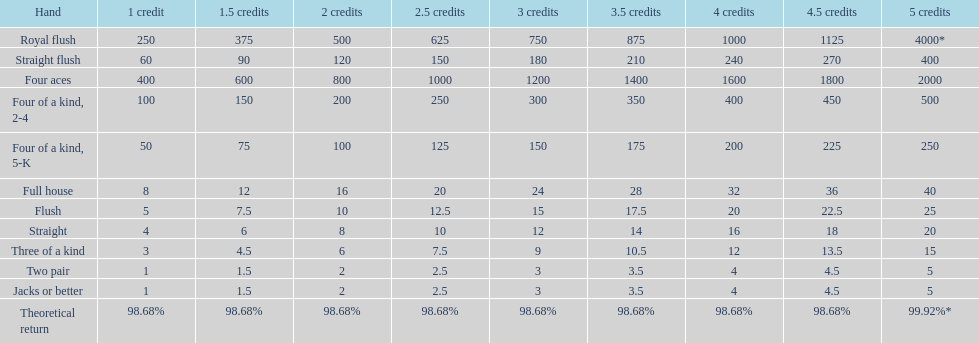Write the full table. {'header': ['Hand', '1 credit', '1.5 credits', '2 credits', '2.5 credits', '3 credits', '3.5 credits', '4 credits', '4.5 credits', '5 credits'], 'rows': [['Royal flush', '250', '375', '500', '625', '750', '875', '1000', '1125', '4000*'], ['Straight flush', '60', '90', '120', '150', '180', '210', '240', '270', '400'], ['Four aces', '400', '600', '800', '1000', '1200', '1400', '1600', '1800', '2000'], ['Four of a kind, 2-4', '100', '150', '200', '250', '300', '350', '400', '450', '500'], ['Four of a kind, 5-K', '50', '75', '100', '125', '150', '175', '200', '225', '250'], ['Full house', '8', '12', '16', '20', '24', '28', '32', '36', '40'], ['Flush', '5', '7.5', '10', '12.5', '15', '17.5', '20', '22.5', '25'], ['Straight', '4', '6', '8', '10', '12', '14', '16', '18', '20'], ['Three of a kind', '3', '4.5', '6', '7.5', '9', '10.5', '12', '13.5', '15'], ['Two pair', '1', '1.5', '2', '2.5', '3', '3.5', '4', '4.5', '5'], ['Jacks or better', '1', '1.5', '2', '2.5', '3', '3.5', '4', '4.5', '5'], ['Theoretical return', '98.68%', '98.68%', '98.68%', '98.68%', '98.68%', '98.68%', '98.68%', '98.68%', '99.92%*']]} Which hand is the top hand in the card game super aces? Royal flush. 